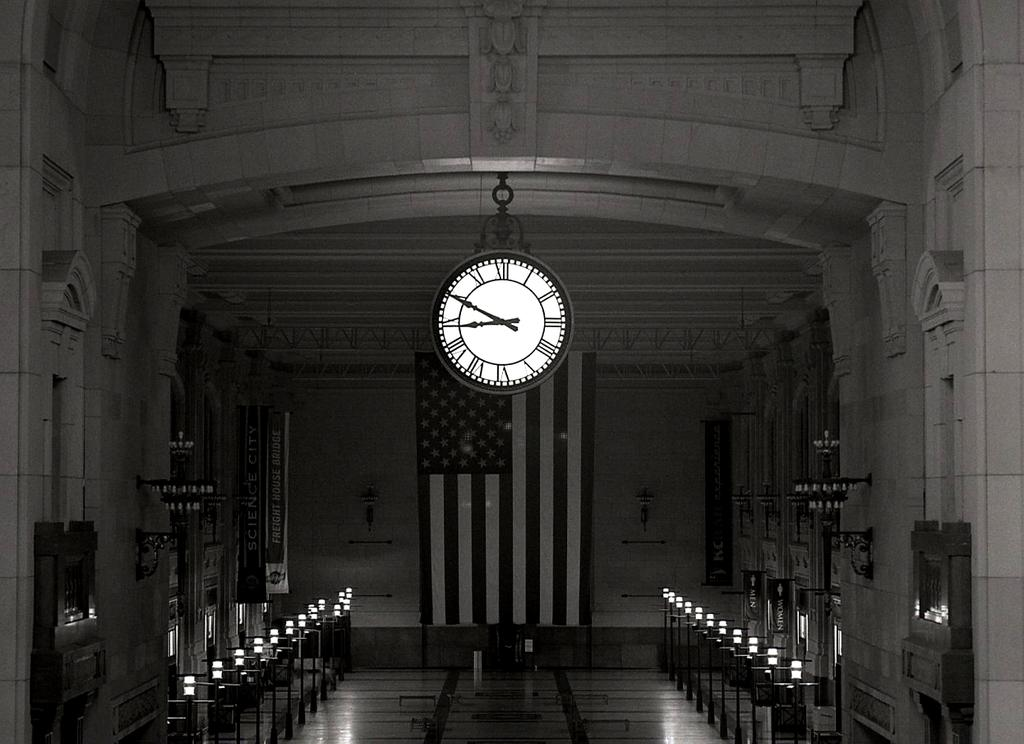<image>
Relay a brief, clear account of the picture shown. Clock inside of a building with the hands at 9 and 10. 